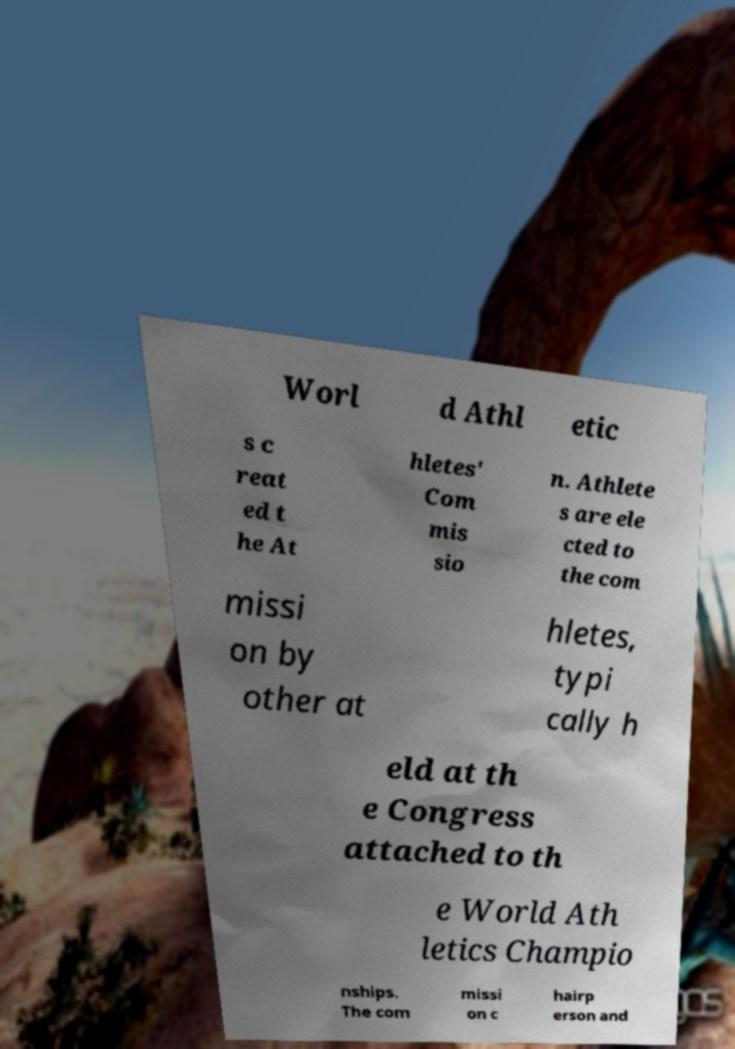Could you extract and type out the text from this image? Worl d Athl etic s c reat ed t he At hletes' Com mis sio n. Athlete s are ele cted to the com missi on by other at hletes, typi cally h eld at th e Congress attached to th e World Ath letics Champio nships. The com missi on c hairp erson and 